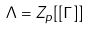Convert formula to latex. <formula><loc_0><loc_0><loc_500><loc_500>\Lambda = Z _ { p } [ [ \Gamma ] ]</formula> 